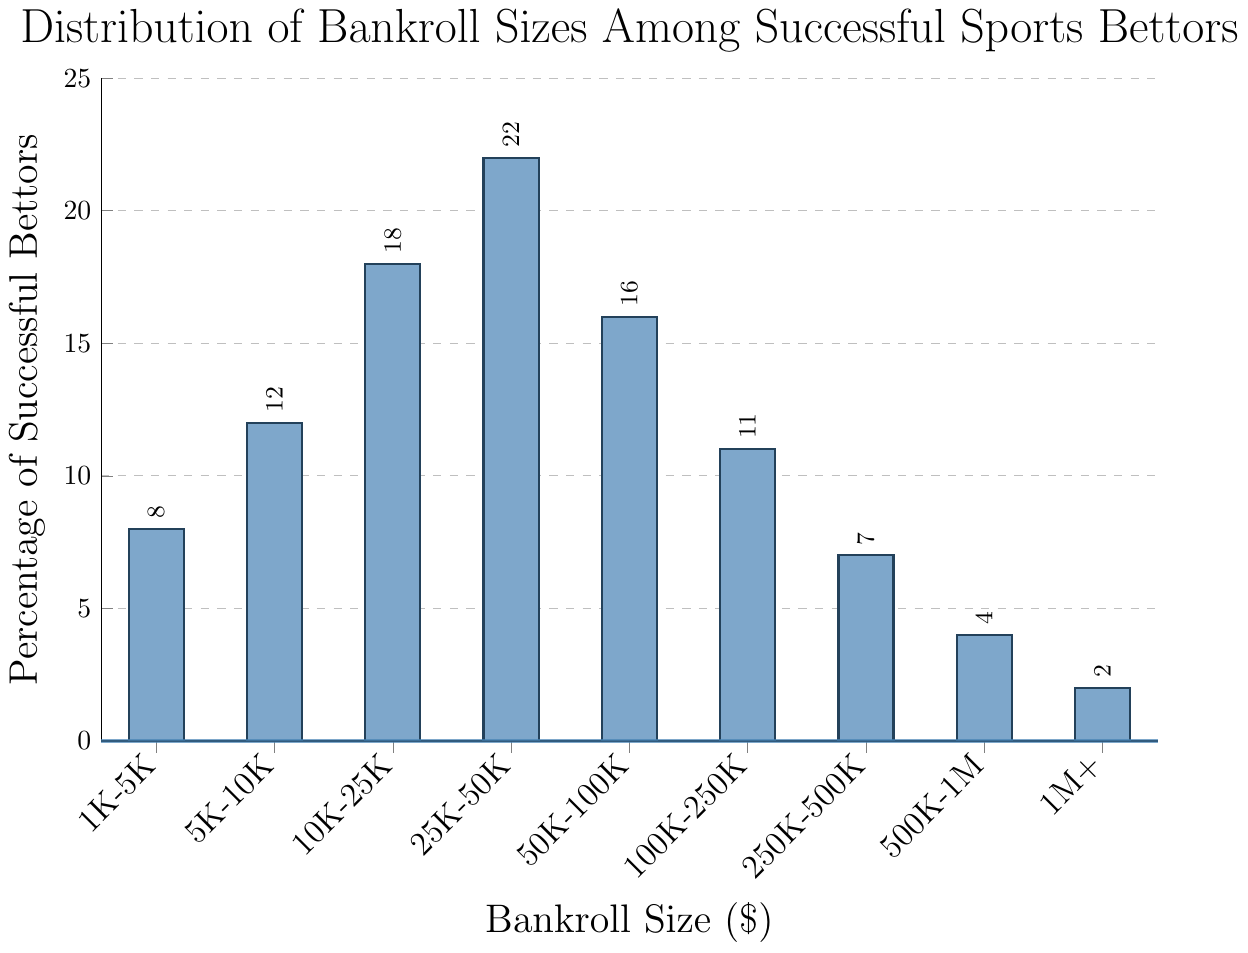what's the range of bankroll sizes that has the highest percentage of successful bettors? The bar representing the range '25001-50000' is the tallest, indicating that this range has the highest percentage.
Answer: 25001-50000 How many bankroll size ranges have more than 10% of successful bettors? Look at the heights of the bars to identify ranges with percentages higher than 10%. These ranges are '5001-10000', '10001-25000', '25001-50000', and '50001-100000'.
Answer: 4 Which bankroll size range has the least percentage of successful bettors? The smallest bar represents '1000001+', indicating that this range has the least percentage.
Answer: 1000001+ Is the percentage of successful bettors in the '50K-100K' range greater than the percentage in the '500K-1M' range? Compare the heights of the bars for '50K-100K' (16%) and '500K-1M' (4%).
Answer: Yes What is the combined percentage of successful bettors with bankroll sizes between '1K-5K' and '5K-10K'? Add the percentages of '1K-5K' (8%) and '5K-10K' (12%).
Answer: 20% Is there a significant drop in percentage after the '25K-50K' bankroll size range? Compare the percentage of '25001-50000' (22%) with '50001-100000' (16%). The drop is 6%, which is significant.
Answer: Yes How many bankroll sizes have a percentage of successful bettors between 5% and 10%? Identify bars within this range: '1000-5000' (8%) and '250001-500000' (7%).
Answer: 2 What is the percentage difference between the highest and lowest bankroll size ranges? Subtract the percentage of '1000001+' (2%) from '25001-50000' (22%).
Answer: 20% Which ranges have a combined percentage of over 30%? Sum combinations of percentages to see which exceed 30%. '10001-25000' (18%) + '25001-50000' (22%) = 40%; '25001-50000' (22%) + '50001-100000' (16%) = 38%.
Answer: 10001-25000 and 25001-50000; 25001-50000 and 50001-100000 